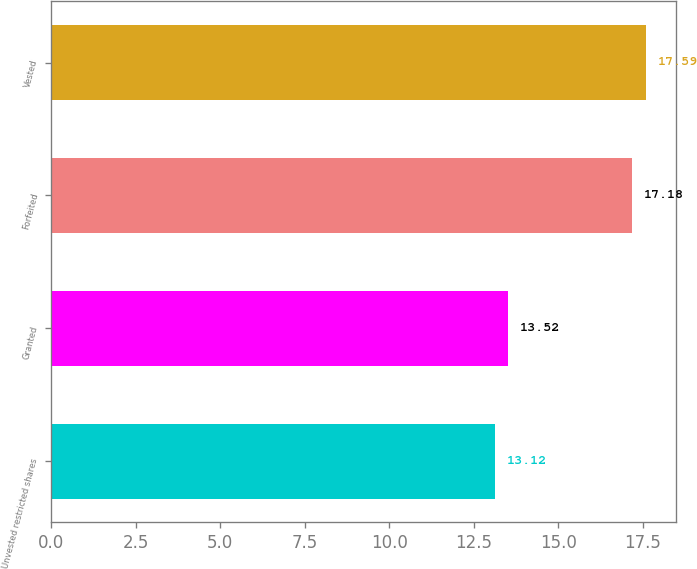Convert chart. <chart><loc_0><loc_0><loc_500><loc_500><bar_chart><fcel>Unvested restricted shares<fcel>Granted<fcel>Forfeited<fcel>Vested<nl><fcel>13.12<fcel>13.52<fcel>17.18<fcel>17.59<nl></chart> 